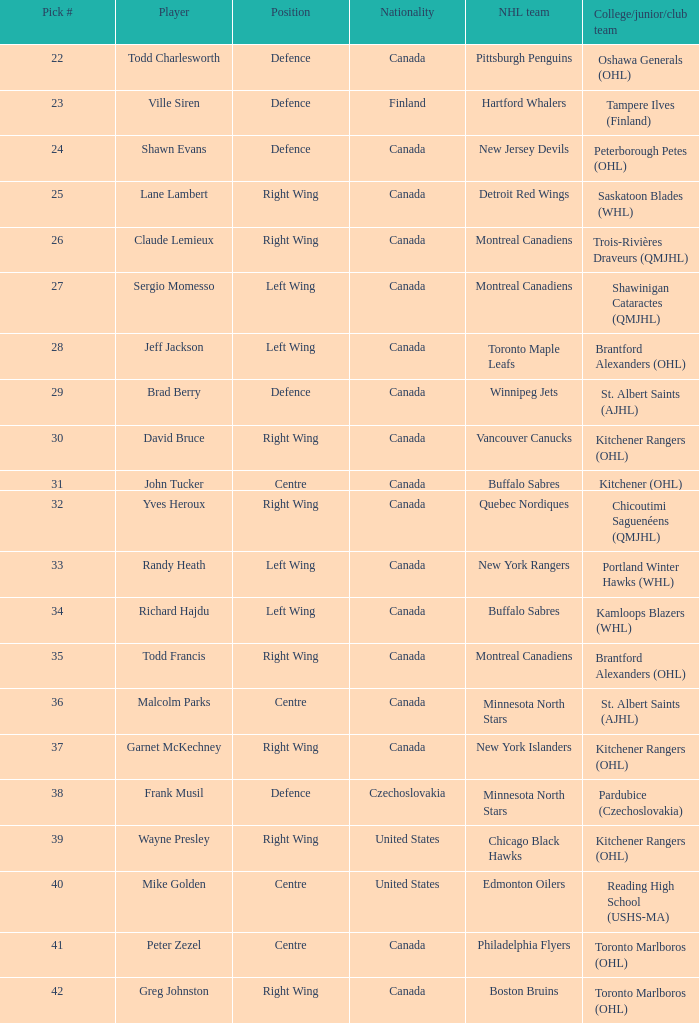How many times does the nhl team winnipeg jets exist? 1.0. 